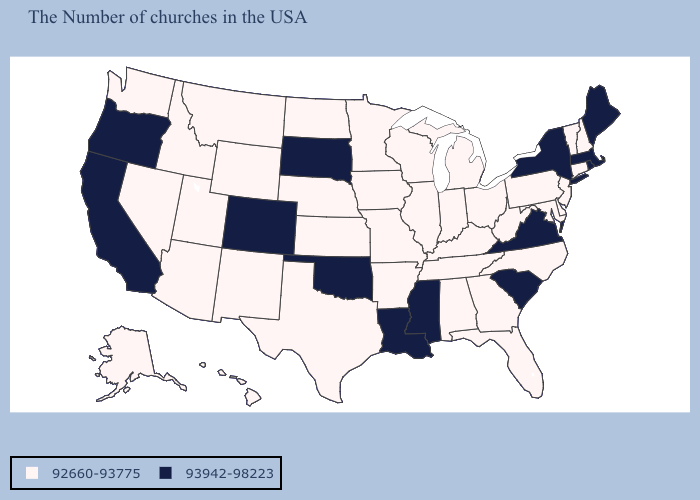Name the states that have a value in the range 92660-93775?
Write a very short answer. New Hampshire, Vermont, Connecticut, New Jersey, Delaware, Maryland, Pennsylvania, North Carolina, West Virginia, Ohio, Florida, Georgia, Michigan, Kentucky, Indiana, Alabama, Tennessee, Wisconsin, Illinois, Missouri, Arkansas, Minnesota, Iowa, Kansas, Nebraska, Texas, North Dakota, Wyoming, New Mexico, Utah, Montana, Arizona, Idaho, Nevada, Washington, Alaska, Hawaii. Among the states that border West Virginia , does Virginia have the lowest value?
Be succinct. No. What is the value of Maine?
Short answer required. 93942-98223. Does Washington have the same value as Michigan?
Short answer required. Yes. Does South Dakota have the lowest value in the MidWest?
Keep it brief. No. Name the states that have a value in the range 93942-98223?
Short answer required. Maine, Massachusetts, Rhode Island, New York, Virginia, South Carolina, Mississippi, Louisiana, Oklahoma, South Dakota, Colorado, California, Oregon. Does Colorado have the highest value in the USA?
Give a very brief answer. Yes. Name the states that have a value in the range 93942-98223?
Keep it brief. Maine, Massachusetts, Rhode Island, New York, Virginia, South Carolina, Mississippi, Louisiana, Oklahoma, South Dakota, Colorado, California, Oregon. Which states have the lowest value in the USA?
Quick response, please. New Hampshire, Vermont, Connecticut, New Jersey, Delaware, Maryland, Pennsylvania, North Carolina, West Virginia, Ohio, Florida, Georgia, Michigan, Kentucky, Indiana, Alabama, Tennessee, Wisconsin, Illinois, Missouri, Arkansas, Minnesota, Iowa, Kansas, Nebraska, Texas, North Dakota, Wyoming, New Mexico, Utah, Montana, Arizona, Idaho, Nevada, Washington, Alaska, Hawaii. Is the legend a continuous bar?
Be succinct. No. Does Florida have the same value as Louisiana?
Concise answer only. No. Which states have the highest value in the USA?
Quick response, please. Maine, Massachusetts, Rhode Island, New York, Virginia, South Carolina, Mississippi, Louisiana, Oklahoma, South Dakota, Colorado, California, Oregon. Does New Mexico have the highest value in the USA?
Quick response, please. No. Name the states that have a value in the range 93942-98223?
Give a very brief answer. Maine, Massachusetts, Rhode Island, New York, Virginia, South Carolina, Mississippi, Louisiana, Oklahoma, South Dakota, Colorado, California, Oregon. 